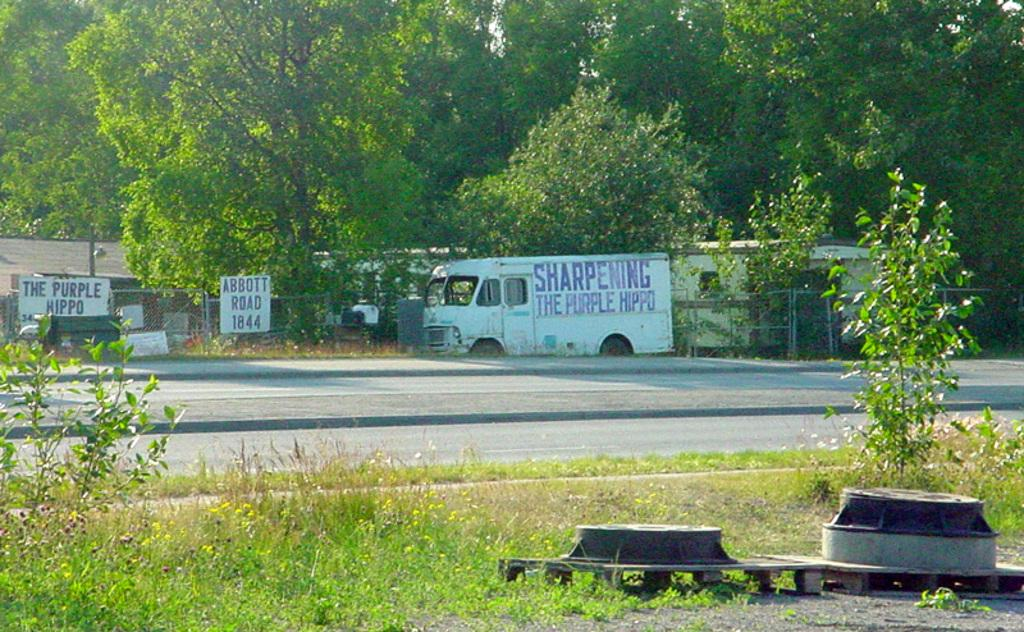What type of vegetation can be seen in the image? There are plants and grassland visible in the image. What is located in the foreground of the image? There are objects in the foreground of the image. What can be seen in the background of the image? There are posters, a vehicle, houses, and trees in the background of the image. What advice is being offered by the tree in the image? There is no advice being offered by the tree in the image, as trees do not communicate in that manner. What type of bit is being used by the vehicle in the image? There is no bit visible in the image, as the vehicle is not engaged in any activity that would require a bit. 